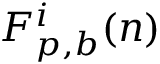<formula> <loc_0><loc_0><loc_500><loc_500>F _ { p , b } ^ { i } ( n )</formula> 